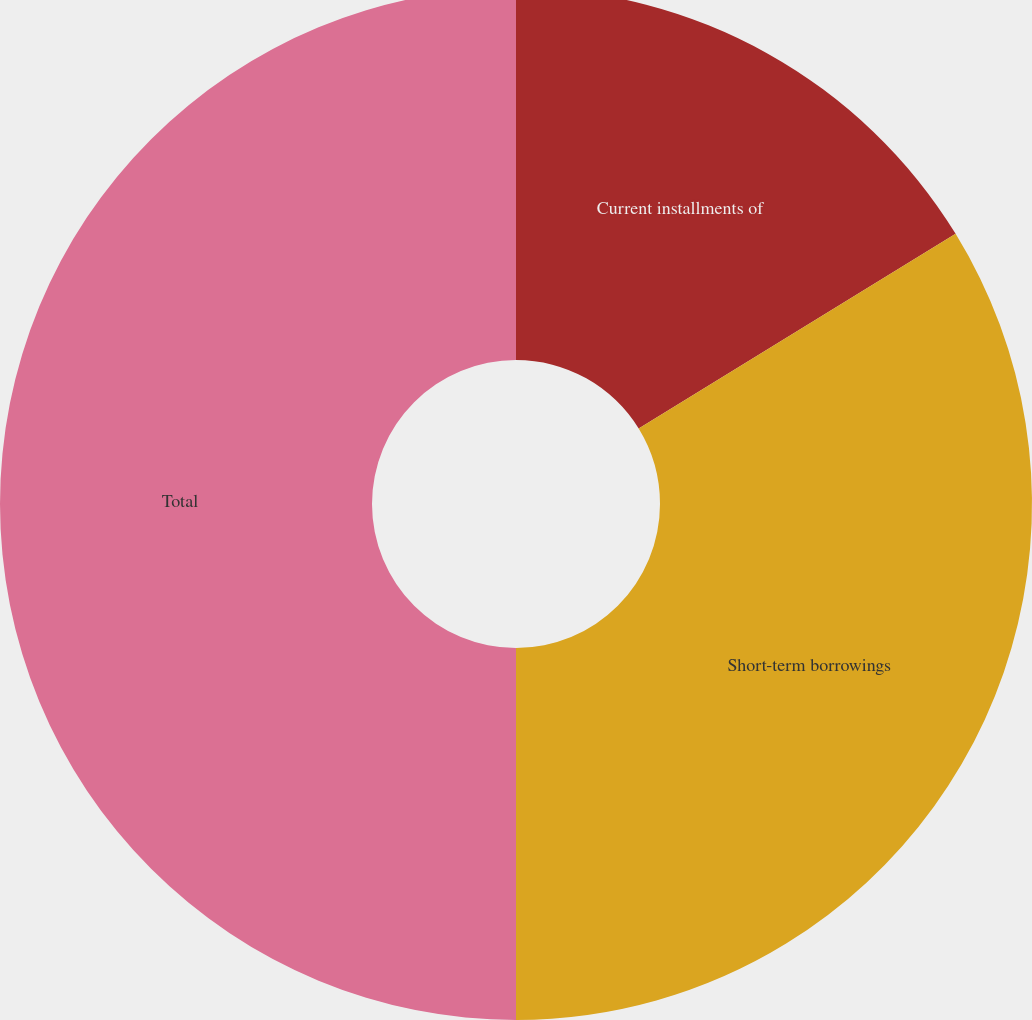Convert chart. <chart><loc_0><loc_0><loc_500><loc_500><pie_chart><fcel>Current installments of<fcel>Short-term borrowings<fcel>Total<nl><fcel>16.23%<fcel>33.77%<fcel>50.0%<nl></chart> 